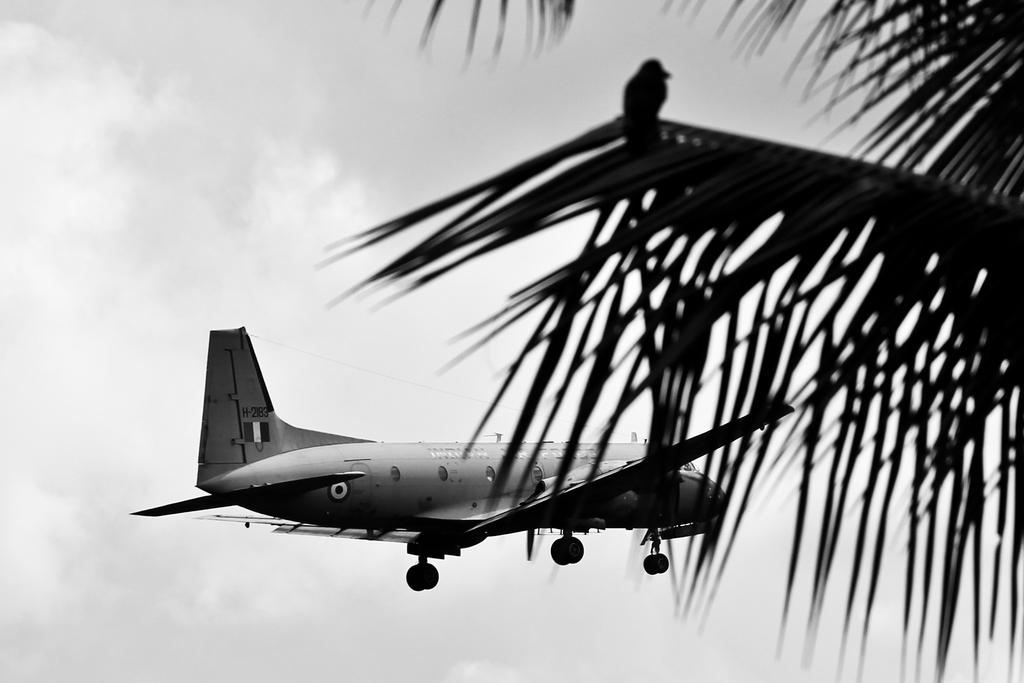What is the main subject of the image? The main subject of the image is a flight, which refers to an airplane. What can be seen on the right side of the image? There are leaves on the right side of the image. What other living creature is present in the image? There is a bird in the image. What is visible in the background of the image? The sky is visible in the background of the image. What type of minister is depicted in the image? There is no minister present in the image; it features an airplane, leaves, a bird, and the sky. Can you tell me how many zippers are visible in the image? There are no zippers present in the image. 